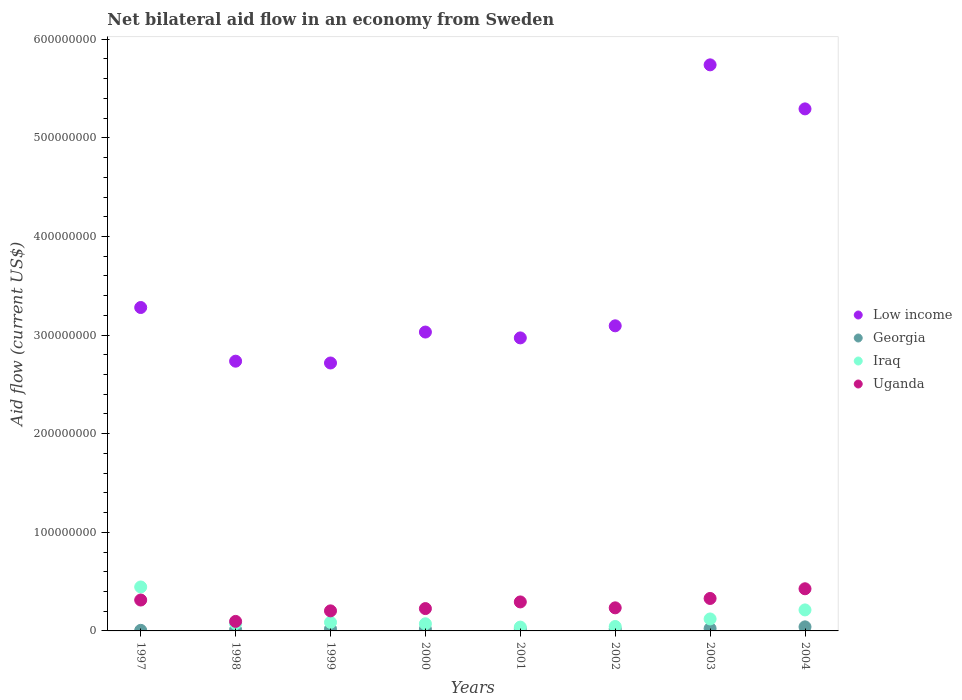How many different coloured dotlines are there?
Provide a short and direct response. 4. What is the net bilateral aid flow in Uganda in 2003?
Offer a terse response. 3.29e+07. Across all years, what is the maximum net bilateral aid flow in Georgia?
Your response must be concise. 4.12e+06. Across all years, what is the minimum net bilateral aid flow in Georgia?
Your answer should be compact. 5.90e+05. In which year was the net bilateral aid flow in Low income minimum?
Ensure brevity in your answer.  1999. What is the total net bilateral aid flow in Uganda in the graph?
Keep it short and to the point. 2.12e+08. What is the difference between the net bilateral aid flow in Low income in 1998 and that in 2001?
Provide a short and direct response. -2.36e+07. What is the difference between the net bilateral aid flow in Georgia in 2001 and the net bilateral aid flow in Uganda in 2000?
Make the answer very short. -2.07e+07. What is the average net bilateral aid flow in Low income per year?
Your answer should be compact. 3.61e+08. In the year 2000, what is the difference between the net bilateral aid flow in Georgia and net bilateral aid flow in Uganda?
Your answer should be very brief. -2.09e+07. What is the ratio of the net bilateral aid flow in Iraq in 1997 to that in 2004?
Ensure brevity in your answer.  2.09. Is the difference between the net bilateral aid flow in Georgia in 1998 and 2004 greater than the difference between the net bilateral aid flow in Uganda in 1998 and 2004?
Offer a very short reply. Yes. What is the difference between the highest and the second highest net bilateral aid flow in Iraq?
Make the answer very short. 2.33e+07. What is the difference between the highest and the lowest net bilateral aid flow in Iraq?
Keep it short and to the point. 4.07e+07. In how many years, is the net bilateral aid flow in Uganda greater than the average net bilateral aid flow in Uganda taken over all years?
Your response must be concise. 4. Is the sum of the net bilateral aid flow in Uganda in 2000 and 2003 greater than the maximum net bilateral aid flow in Iraq across all years?
Your response must be concise. Yes. Does the net bilateral aid flow in Uganda monotonically increase over the years?
Your answer should be very brief. No. Is the net bilateral aid flow in Iraq strictly greater than the net bilateral aid flow in Low income over the years?
Offer a terse response. No. How many years are there in the graph?
Your response must be concise. 8. Does the graph contain grids?
Keep it short and to the point. No. Where does the legend appear in the graph?
Provide a succinct answer. Center right. How many legend labels are there?
Give a very brief answer. 4. What is the title of the graph?
Your answer should be compact. Net bilateral aid flow in an economy from Sweden. Does "Sao Tome and Principe" appear as one of the legend labels in the graph?
Your answer should be very brief. No. What is the label or title of the Y-axis?
Offer a very short reply. Aid flow (current US$). What is the Aid flow (current US$) in Low income in 1997?
Give a very brief answer. 3.28e+08. What is the Aid flow (current US$) in Georgia in 1997?
Keep it short and to the point. 5.90e+05. What is the Aid flow (current US$) of Iraq in 1997?
Provide a short and direct response. 4.46e+07. What is the Aid flow (current US$) in Uganda in 1997?
Ensure brevity in your answer.  3.13e+07. What is the Aid flow (current US$) of Low income in 1998?
Provide a short and direct response. 2.74e+08. What is the Aid flow (current US$) in Georgia in 1998?
Offer a very short reply. 1.27e+06. What is the Aid flow (current US$) in Iraq in 1998?
Your answer should be very brief. 7.46e+06. What is the Aid flow (current US$) of Uganda in 1998?
Offer a terse response. 9.65e+06. What is the Aid flow (current US$) in Low income in 1999?
Provide a short and direct response. 2.72e+08. What is the Aid flow (current US$) of Georgia in 1999?
Your answer should be very brief. 2.03e+06. What is the Aid flow (current US$) in Iraq in 1999?
Provide a succinct answer. 8.66e+06. What is the Aid flow (current US$) in Uganda in 1999?
Ensure brevity in your answer.  2.03e+07. What is the Aid flow (current US$) of Low income in 2000?
Offer a terse response. 3.03e+08. What is the Aid flow (current US$) in Georgia in 2000?
Your response must be concise. 1.77e+06. What is the Aid flow (current US$) of Iraq in 2000?
Provide a succinct answer. 7.23e+06. What is the Aid flow (current US$) of Uganda in 2000?
Provide a succinct answer. 2.26e+07. What is the Aid flow (current US$) of Low income in 2001?
Ensure brevity in your answer.  2.97e+08. What is the Aid flow (current US$) of Georgia in 2001?
Ensure brevity in your answer.  1.99e+06. What is the Aid flow (current US$) of Iraq in 2001?
Provide a short and direct response. 3.87e+06. What is the Aid flow (current US$) in Uganda in 2001?
Give a very brief answer. 2.94e+07. What is the Aid flow (current US$) in Low income in 2002?
Ensure brevity in your answer.  3.09e+08. What is the Aid flow (current US$) of Georgia in 2002?
Your answer should be very brief. 2.02e+06. What is the Aid flow (current US$) of Iraq in 2002?
Give a very brief answer. 4.50e+06. What is the Aid flow (current US$) in Uganda in 2002?
Ensure brevity in your answer.  2.34e+07. What is the Aid flow (current US$) of Low income in 2003?
Your answer should be very brief. 5.74e+08. What is the Aid flow (current US$) of Georgia in 2003?
Give a very brief answer. 2.42e+06. What is the Aid flow (current US$) in Iraq in 2003?
Keep it short and to the point. 1.21e+07. What is the Aid flow (current US$) in Uganda in 2003?
Make the answer very short. 3.29e+07. What is the Aid flow (current US$) in Low income in 2004?
Your answer should be very brief. 5.29e+08. What is the Aid flow (current US$) in Georgia in 2004?
Your answer should be compact. 4.12e+06. What is the Aid flow (current US$) of Iraq in 2004?
Your answer should be very brief. 2.13e+07. What is the Aid flow (current US$) of Uganda in 2004?
Provide a succinct answer. 4.27e+07. Across all years, what is the maximum Aid flow (current US$) of Low income?
Provide a short and direct response. 5.74e+08. Across all years, what is the maximum Aid flow (current US$) of Georgia?
Your response must be concise. 4.12e+06. Across all years, what is the maximum Aid flow (current US$) of Iraq?
Keep it short and to the point. 4.46e+07. Across all years, what is the maximum Aid flow (current US$) of Uganda?
Your response must be concise. 4.27e+07. Across all years, what is the minimum Aid flow (current US$) of Low income?
Your answer should be very brief. 2.72e+08. Across all years, what is the minimum Aid flow (current US$) in Georgia?
Ensure brevity in your answer.  5.90e+05. Across all years, what is the minimum Aid flow (current US$) in Iraq?
Ensure brevity in your answer.  3.87e+06. Across all years, what is the minimum Aid flow (current US$) in Uganda?
Provide a short and direct response. 9.65e+06. What is the total Aid flow (current US$) in Low income in the graph?
Ensure brevity in your answer.  2.89e+09. What is the total Aid flow (current US$) in Georgia in the graph?
Ensure brevity in your answer.  1.62e+07. What is the total Aid flow (current US$) of Iraq in the graph?
Your answer should be very brief. 1.10e+08. What is the total Aid flow (current US$) in Uganda in the graph?
Offer a very short reply. 2.12e+08. What is the difference between the Aid flow (current US$) in Low income in 1997 and that in 1998?
Ensure brevity in your answer.  5.44e+07. What is the difference between the Aid flow (current US$) of Georgia in 1997 and that in 1998?
Provide a succinct answer. -6.80e+05. What is the difference between the Aid flow (current US$) of Iraq in 1997 and that in 1998?
Give a very brief answer. 3.71e+07. What is the difference between the Aid flow (current US$) of Uganda in 1997 and that in 1998?
Give a very brief answer. 2.17e+07. What is the difference between the Aid flow (current US$) of Low income in 1997 and that in 1999?
Provide a short and direct response. 5.63e+07. What is the difference between the Aid flow (current US$) of Georgia in 1997 and that in 1999?
Your answer should be very brief. -1.44e+06. What is the difference between the Aid flow (current US$) in Iraq in 1997 and that in 1999?
Make the answer very short. 3.59e+07. What is the difference between the Aid flow (current US$) in Uganda in 1997 and that in 1999?
Your response must be concise. 1.10e+07. What is the difference between the Aid flow (current US$) of Low income in 1997 and that in 2000?
Give a very brief answer. 2.49e+07. What is the difference between the Aid flow (current US$) of Georgia in 1997 and that in 2000?
Offer a terse response. -1.18e+06. What is the difference between the Aid flow (current US$) in Iraq in 1997 and that in 2000?
Keep it short and to the point. 3.73e+07. What is the difference between the Aid flow (current US$) in Uganda in 1997 and that in 2000?
Provide a short and direct response. 8.68e+06. What is the difference between the Aid flow (current US$) in Low income in 1997 and that in 2001?
Offer a terse response. 3.08e+07. What is the difference between the Aid flow (current US$) in Georgia in 1997 and that in 2001?
Your answer should be very brief. -1.40e+06. What is the difference between the Aid flow (current US$) in Iraq in 1997 and that in 2001?
Provide a short and direct response. 4.07e+07. What is the difference between the Aid flow (current US$) in Uganda in 1997 and that in 2001?
Give a very brief answer. 1.93e+06. What is the difference between the Aid flow (current US$) of Low income in 1997 and that in 2002?
Give a very brief answer. 1.86e+07. What is the difference between the Aid flow (current US$) of Georgia in 1997 and that in 2002?
Give a very brief answer. -1.43e+06. What is the difference between the Aid flow (current US$) in Iraq in 1997 and that in 2002?
Your answer should be compact. 4.01e+07. What is the difference between the Aid flow (current US$) of Uganda in 1997 and that in 2002?
Keep it short and to the point. 7.92e+06. What is the difference between the Aid flow (current US$) of Low income in 1997 and that in 2003?
Your response must be concise. -2.46e+08. What is the difference between the Aid flow (current US$) of Georgia in 1997 and that in 2003?
Your answer should be compact. -1.83e+06. What is the difference between the Aid flow (current US$) of Iraq in 1997 and that in 2003?
Provide a succinct answer. 3.24e+07. What is the difference between the Aid flow (current US$) of Uganda in 1997 and that in 2003?
Keep it short and to the point. -1.59e+06. What is the difference between the Aid flow (current US$) of Low income in 1997 and that in 2004?
Your answer should be very brief. -2.01e+08. What is the difference between the Aid flow (current US$) of Georgia in 1997 and that in 2004?
Your answer should be compact. -3.53e+06. What is the difference between the Aid flow (current US$) of Iraq in 1997 and that in 2004?
Make the answer very short. 2.33e+07. What is the difference between the Aid flow (current US$) of Uganda in 1997 and that in 2004?
Ensure brevity in your answer.  -1.14e+07. What is the difference between the Aid flow (current US$) in Low income in 1998 and that in 1999?
Make the answer very short. 1.84e+06. What is the difference between the Aid flow (current US$) in Georgia in 1998 and that in 1999?
Offer a terse response. -7.60e+05. What is the difference between the Aid flow (current US$) in Iraq in 1998 and that in 1999?
Make the answer very short. -1.20e+06. What is the difference between the Aid flow (current US$) in Uganda in 1998 and that in 1999?
Keep it short and to the point. -1.07e+07. What is the difference between the Aid flow (current US$) in Low income in 1998 and that in 2000?
Your answer should be compact. -2.95e+07. What is the difference between the Aid flow (current US$) of Georgia in 1998 and that in 2000?
Offer a terse response. -5.00e+05. What is the difference between the Aid flow (current US$) in Iraq in 1998 and that in 2000?
Provide a short and direct response. 2.30e+05. What is the difference between the Aid flow (current US$) in Uganda in 1998 and that in 2000?
Your answer should be very brief. -1.30e+07. What is the difference between the Aid flow (current US$) of Low income in 1998 and that in 2001?
Offer a terse response. -2.36e+07. What is the difference between the Aid flow (current US$) of Georgia in 1998 and that in 2001?
Offer a very short reply. -7.20e+05. What is the difference between the Aid flow (current US$) in Iraq in 1998 and that in 2001?
Ensure brevity in your answer.  3.59e+06. What is the difference between the Aid flow (current US$) of Uganda in 1998 and that in 2001?
Offer a very short reply. -1.98e+07. What is the difference between the Aid flow (current US$) in Low income in 1998 and that in 2002?
Your answer should be compact. -3.59e+07. What is the difference between the Aid flow (current US$) of Georgia in 1998 and that in 2002?
Your answer should be compact. -7.50e+05. What is the difference between the Aid flow (current US$) of Iraq in 1998 and that in 2002?
Give a very brief answer. 2.96e+06. What is the difference between the Aid flow (current US$) of Uganda in 1998 and that in 2002?
Your answer should be compact. -1.38e+07. What is the difference between the Aid flow (current US$) in Low income in 1998 and that in 2003?
Ensure brevity in your answer.  -3.00e+08. What is the difference between the Aid flow (current US$) in Georgia in 1998 and that in 2003?
Your response must be concise. -1.15e+06. What is the difference between the Aid flow (current US$) in Iraq in 1998 and that in 2003?
Provide a succinct answer. -4.67e+06. What is the difference between the Aid flow (current US$) of Uganda in 1998 and that in 2003?
Offer a very short reply. -2.33e+07. What is the difference between the Aid flow (current US$) in Low income in 1998 and that in 2004?
Your response must be concise. -2.56e+08. What is the difference between the Aid flow (current US$) of Georgia in 1998 and that in 2004?
Ensure brevity in your answer.  -2.85e+06. What is the difference between the Aid flow (current US$) in Iraq in 1998 and that in 2004?
Provide a short and direct response. -1.38e+07. What is the difference between the Aid flow (current US$) in Uganda in 1998 and that in 2004?
Provide a short and direct response. -3.31e+07. What is the difference between the Aid flow (current US$) in Low income in 1999 and that in 2000?
Ensure brevity in your answer.  -3.14e+07. What is the difference between the Aid flow (current US$) in Georgia in 1999 and that in 2000?
Offer a terse response. 2.60e+05. What is the difference between the Aid flow (current US$) in Iraq in 1999 and that in 2000?
Your answer should be very brief. 1.43e+06. What is the difference between the Aid flow (current US$) in Uganda in 1999 and that in 2000?
Provide a succinct answer. -2.31e+06. What is the difference between the Aid flow (current US$) in Low income in 1999 and that in 2001?
Offer a very short reply. -2.54e+07. What is the difference between the Aid flow (current US$) of Iraq in 1999 and that in 2001?
Your answer should be compact. 4.79e+06. What is the difference between the Aid flow (current US$) in Uganda in 1999 and that in 2001?
Offer a very short reply. -9.06e+06. What is the difference between the Aid flow (current US$) in Low income in 1999 and that in 2002?
Offer a terse response. -3.77e+07. What is the difference between the Aid flow (current US$) in Iraq in 1999 and that in 2002?
Ensure brevity in your answer.  4.16e+06. What is the difference between the Aid flow (current US$) of Uganda in 1999 and that in 2002?
Offer a very short reply. -3.07e+06. What is the difference between the Aid flow (current US$) of Low income in 1999 and that in 2003?
Your response must be concise. -3.02e+08. What is the difference between the Aid flow (current US$) of Georgia in 1999 and that in 2003?
Provide a short and direct response. -3.90e+05. What is the difference between the Aid flow (current US$) of Iraq in 1999 and that in 2003?
Give a very brief answer. -3.47e+06. What is the difference between the Aid flow (current US$) of Uganda in 1999 and that in 2003?
Offer a terse response. -1.26e+07. What is the difference between the Aid flow (current US$) in Low income in 1999 and that in 2004?
Offer a terse response. -2.58e+08. What is the difference between the Aid flow (current US$) of Georgia in 1999 and that in 2004?
Offer a terse response. -2.09e+06. What is the difference between the Aid flow (current US$) of Iraq in 1999 and that in 2004?
Your response must be concise. -1.26e+07. What is the difference between the Aid flow (current US$) in Uganda in 1999 and that in 2004?
Offer a terse response. -2.24e+07. What is the difference between the Aid flow (current US$) of Low income in 2000 and that in 2001?
Keep it short and to the point. 5.94e+06. What is the difference between the Aid flow (current US$) in Georgia in 2000 and that in 2001?
Offer a terse response. -2.20e+05. What is the difference between the Aid flow (current US$) in Iraq in 2000 and that in 2001?
Your answer should be very brief. 3.36e+06. What is the difference between the Aid flow (current US$) of Uganda in 2000 and that in 2001?
Provide a succinct answer. -6.75e+06. What is the difference between the Aid flow (current US$) of Low income in 2000 and that in 2002?
Make the answer very short. -6.32e+06. What is the difference between the Aid flow (current US$) of Georgia in 2000 and that in 2002?
Provide a short and direct response. -2.50e+05. What is the difference between the Aid flow (current US$) of Iraq in 2000 and that in 2002?
Ensure brevity in your answer.  2.73e+06. What is the difference between the Aid flow (current US$) of Uganda in 2000 and that in 2002?
Offer a very short reply. -7.60e+05. What is the difference between the Aid flow (current US$) of Low income in 2000 and that in 2003?
Give a very brief answer. -2.71e+08. What is the difference between the Aid flow (current US$) in Georgia in 2000 and that in 2003?
Offer a very short reply. -6.50e+05. What is the difference between the Aid flow (current US$) in Iraq in 2000 and that in 2003?
Provide a short and direct response. -4.90e+06. What is the difference between the Aid flow (current US$) of Uganda in 2000 and that in 2003?
Offer a very short reply. -1.03e+07. What is the difference between the Aid flow (current US$) in Low income in 2000 and that in 2004?
Provide a short and direct response. -2.26e+08. What is the difference between the Aid flow (current US$) of Georgia in 2000 and that in 2004?
Offer a terse response. -2.35e+06. What is the difference between the Aid flow (current US$) in Iraq in 2000 and that in 2004?
Provide a succinct answer. -1.41e+07. What is the difference between the Aid flow (current US$) of Uganda in 2000 and that in 2004?
Offer a very short reply. -2.01e+07. What is the difference between the Aid flow (current US$) of Low income in 2001 and that in 2002?
Keep it short and to the point. -1.23e+07. What is the difference between the Aid flow (current US$) of Iraq in 2001 and that in 2002?
Offer a very short reply. -6.30e+05. What is the difference between the Aid flow (current US$) of Uganda in 2001 and that in 2002?
Provide a succinct answer. 5.99e+06. What is the difference between the Aid flow (current US$) in Low income in 2001 and that in 2003?
Ensure brevity in your answer.  -2.77e+08. What is the difference between the Aid flow (current US$) in Georgia in 2001 and that in 2003?
Give a very brief answer. -4.30e+05. What is the difference between the Aid flow (current US$) of Iraq in 2001 and that in 2003?
Make the answer very short. -8.26e+06. What is the difference between the Aid flow (current US$) in Uganda in 2001 and that in 2003?
Your answer should be very brief. -3.52e+06. What is the difference between the Aid flow (current US$) in Low income in 2001 and that in 2004?
Ensure brevity in your answer.  -2.32e+08. What is the difference between the Aid flow (current US$) in Georgia in 2001 and that in 2004?
Provide a succinct answer. -2.13e+06. What is the difference between the Aid flow (current US$) of Iraq in 2001 and that in 2004?
Your response must be concise. -1.74e+07. What is the difference between the Aid flow (current US$) in Uganda in 2001 and that in 2004?
Your response must be concise. -1.33e+07. What is the difference between the Aid flow (current US$) of Low income in 2002 and that in 2003?
Provide a short and direct response. -2.65e+08. What is the difference between the Aid flow (current US$) of Georgia in 2002 and that in 2003?
Make the answer very short. -4.00e+05. What is the difference between the Aid flow (current US$) in Iraq in 2002 and that in 2003?
Keep it short and to the point. -7.63e+06. What is the difference between the Aid flow (current US$) of Uganda in 2002 and that in 2003?
Offer a very short reply. -9.51e+06. What is the difference between the Aid flow (current US$) in Low income in 2002 and that in 2004?
Make the answer very short. -2.20e+08. What is the difference between the Aid flow (current US$) in Georgia in 2002 and that in 2004?
Ensure brevity in your answer.  -2.10e+06. What is the difference between the Aid flow (current US$) in Iraq in 2002 and that in 2004?
Give a very brief answer. -1.68e+07. What is the difference between the Aid flow (current US$) of Uganda in 2002 and that in 2004?
Your answer should be very brief. -1.93e+07. What is the difference between the Aid flow (current US$) of Low income in 2003 and that in 2004?
Provide a short and direct response. 4.47e+07. What is the difference between the Aid flow (current US$) of Georgia in 2003 and that in 2004?
Make the answer very short. -1.70e+06. What is the difference between the Aid flow (current US$) of Iraq in 2003 and that in 2004?
Your response must be concise. -9.17e+06. What is the difference between the Aid flow (current US$) of Uganda in 2003 and that in 2004?
Keep it short and to the point. -9.82e+06. What is the difference between the Aid flow (current US$) in Low income in 1997 and the Aid flow (current US$) in Georgia in 1998?
Provide a short and direct response. 3.27e+08. What is the difference between the Aid flow (current US$) of Low income in 1997 and the Aid flow (current US$) of Iraq in 1998?
Ensure brevity in your answer.  3.21e+08. What is the difference between the Aid flow (current US$) of Low income in 1997 and the Aid flow (current US$) of Uganda in 1998?
Your answer should be compact. 3.18e+08. What is the difference between the Aid flow (current US$) of Georgia in 1997 and the Aid flow (current US$) of Iraq in 1998?
Your answer should be compact. -6.87e+06. What is the difference between the Aid flow (current US$) of Georgia in 1997 and the Aid flow (current US$) of Uganda in 1998?
Ensure brevity in your answer.  -9.06e+06. What is the difference between the Aid flow (current US$) in Iraq in 1997 and the Aid flow (current US$) in Uganda in 1998?
Your response must be concise. 3.49e+07. What is the difference between the Aid flow (current US$) in Low income in 1997 and the Aid flow (current US$) in Georgia in 1999?
Make the answer very short. 3.26e+08. What is the difference between the Aid flow (current US$) in Low income in 1997 and the Aid flow (current US$) in Iraq in 1999?
Offer a very short reply. 3.19e+08. What is the difference between the Aid flow (current US$) in Low income in 1997 and the Aid flow (current US$) in Uganda in 1999?
Give a very brief answer. 3.08e+08. What is the difference between the Aid flow (current US$) in Georgia in 1997 and the Aid flow (current US$) in Iraq in 1999?
Your answer should be very brief. -8.07e+06. What is the difference between the Aid flow (current US$) of Georgia in 1997 and the Aid flow (current US$) of Uganda in 1999?
Ensure brevity in your answer.  -1.98e+07. What is the difference between the Aid flow (current US$) of Iraq in 1997 and the Aid flow (current US$) of Uganda in 1999?
Your response must be concise. 2.42e+07. What is the difference between the Aid flow (current US$) in Low income in 1997 and the Aid flow (current US$) in Georgia in 2000?
Your answer should be very brief. 3.26e+08. What is the difference between the Aid flow (current US$) of Low income in 1997 and the Aid flow (current US$) of Iraq in 2000?
Make the answer very short. 3.21e+08. What is the difference between the Aid flow (current US$) of Low income in 1997 and the Aid flow (current US$) of Uganda in 2000?
Give a very brief answer. 3.05e+08. What is the difference between the Aid flow (current US$) of Georgia in 1997 and the Aid flow (current US$) of Iraq in 2000?
Provide a succinct answer. -6.64e+06. What is the difference between the Aid flow (current US$) in Georgia in 1997 and the Aid flow (current US$) in Uganda in 2000?
Provide a short and direct response. -2.21e+07. What is the difference between the Aid flow (current US$) in Iraq in 1997 and the Aid flow (current US$) in Uganda in 2000?
Your answer should be very brief. 2.19e+07. What is the difference between the Aid flow (current US$) in Low income in 1997 and the Aid flow (current US$) in Georgia in 2001?
Provide a short and direct response. 3.26e+08. What is the difference between the Aid flow (current US$) in Low income in 1997 and the Aid flow (current US$) in Iraq in 2001?
Offer a very short reply. 3.24e+08. What is the difference between the Aid flow (current US$) of Low income in 1997 and the Aid flow (current US$) of Uganda in 2001?
Provide a short and direct response. 2.99e+08. What is the difference between the Aid flow (current US$) in Georgia in 1997 and the Aid flow (current US$) in Iraq in 2001?
Your answer should be very brief. -3.28e+06. What is the difference between the Aid flow (current US$) of Georgia in 1997 and the Aid flow (current US$) of Uganda in 2001?
Ensure brevity in your answer.  -2.88e+07. What is the difference between the Aid flow (current US$) in Iraq in 1997 and the Aid flow (current US$) in Uganda in 2001?
Your answer should be very brief. 1.52e+07. What is the difference between the Aid flow (current US$) in Low income in 1997 and the Aid flow (current US$) in Georgia in 2002?
Give a very brief answer. 3.26e+08. What is the difference between the Aid flow (current US$) in Low income in 1997 and the Aid flow (current US$) in Iraq in 2002?
Ensure brevity in your answer.  3.23e+08. What is the difference between the Aid flow (current US$) of Low income in 1997 and the Aid flow (current US$) of Uganda in 2002?
Keep it short and to the point. 3.05e+08. What is the difference between the Aid flow (current US$) of Georgia in 1997 and the Aid flow (current US$) of Iraq in 2002?
Provide a succinct answer. -3.91e+06. What is the difference between the Aid flow (current US$) of Georgia in 1997 and the Aid flow (current US$) of Uganda in 2002?
Your response must be concise. -2.28e+07. What is the difference between the Aid flow (current US$) in Iraq in 1997 and the Aid flow (current US$) in Uganda in 2002?
Your answer should be compact. 2.12e+07. What is the difference between the Aid flow (current US$) in Low income in 1997 and the Aid flow (current US$) in Georgia in 2003?
Your answer should be compact. 3.26e+08. What is the difference between the Aid flow (current US$) in Low income in 1997 and the Aid flow (current US$) in Iraq in 2003?
Make the answer very short. 3.16e+08. What is the difference between the Aid flow (current US$) of Low income in 1997 and the Aid flow (current US$) of Uganda in 2003?
Your answer should be very brief. 2.95e+08. What is the difference between the Aid flow (current US$) of Georgia in 1997 and the Aid flow (current US$) of Iraq in 2003?
Your response must be concise. -1.15e+07. What is the difference between the Aid flow (current US$) of Georgia in 1997 and the Aid flow (current US$) of Uganda in 2003?
Ensure brevity in your answer.  -3.23e+07. What is the difference between the Aid flow (current US$) of Iraq in 1997 and the Aid flow (current US$) of Uganda in 2003?
Keep it short and to the point. 1.16e+07. What is the difference between the Aid flow (current US$) in Low income in 1997 and the Aid flow (current US$) in Georgia in 2004?
Make the answer very short. 3.24e+08. What is the difference between the Aid flow (current US$) in Low income in 1997 and the Aid flow (current US$) in Iraq in 2004?
Provide a succinct answer. 3.07e+08. What is the difference between the Aid flow (current US$) in Low income in 1997 and the Aid flow (current US$) in Uganda in 2004?
Provide a short and direct response. 2.85e+08. What is the difference between the Aid flow (current US$) in Georgia in 1997 and the Aid flow (current US$) in Iraq in 2004?
Keep it short and to the point. -2.07e+07. What is the difference between the Aid flow (current US$) in Georgia in 1997 and the Aid flow (current US$) in Uganda in 2004?
Provide a succinct answer. -4.22e+07. What is the difference between the Aid flow (current US$) of Iraq in 1997 and the Aid flow (current US$) of Uganda in 2004?
Offer a very short reply. 1.83e+06. What is the difference between the Aid flow (current US$) of Low income in 1998 and the Aid flow (current US$) of Georgia in 1999?
Your answer should be compact. 2.72e+08. What is the difference between the Aid flow (current US$) in Low income in 1998 and the Aid flow (current US$) in Iraq in 1999?
Offer a very short reply. 2.65e+08. What is the difference between the Aid flow (current US$) of Low income in 1998 and the Aid flow (current US$) of Uganda in 1999?
Provide a short and direct response. 2.53e+08. What is the difference between the Aid flow (current US$) in Georgia in 1998 and the Aid flow (current US$) in Iraq in 1999?
Your response must be concise. -7.39e+06. What is the difference between the Aid flow (current US$) in Georgia in 1998 and the Aid flow (current US$) in Uganda in 1999?
Your response must be concise. -1.91e+07. What is the difference between the Aid flow (current US$) in Iraq in 1998 and the Aid flow (current US$) in Uganda in 1999?
Make the answer very short. -1.29e+07. What is the difference between the Aid flow (current US$) in Low income in 1998 and the Aid flow (current US$) in Georgia in 2000?
Offer a terse response. 2.72e+08. What is the difference between the Aid flow (current US$) of Low income in 1998 and the Aid flow (current US$) of Iraq in 2000?
Make the answer very short. 2.66e+08. What is the difference between the Aid flow (current US$) of Low income in 1998 and the Aid flow (current US$) of Uganda in 2000?
Provide a succinct answer. 2.51e+08. What is the difference between the Aid flow (current US$) in Georgia in 1998 and the Aid flow (current US$) in Iraq in 2000?
Provide a short and direct response. -5.96e+06. What is the difference between the Aid flow (current US$) of Georgia in 1998 and the Aid flow (current US$) of Uganda in 2000?
Your answer should be very brief. -2.14e+07. What is the difference between the Aid flow (current US$) in Iraq in 1998 and the Aid flow (current US$) in Uganda in 2000?
Provide a short and direct response. -1.52e+07. What is the difference between the Aid flow (current US$) in Low income in 1998 and the Aid flow (current US$) in Georgia in 2001?
Your response must be concise. 2.72e+08. What is the difference between the Aid flow (current US$) in Low income in 1998 and the Aid flow (current US$) in Iraq in 2001?
Offer a terse response. 2.70e+08. What is the difference between the Aid flow (current US$) in Low income in 1998 and the Aid flow (current US$) in Uganda in 2001?
Keep it short and to the point. 2.44e+08. What is the difference between the Aid flow (current US$) of Georgia in 1998 and the Aid flow (current US$) of Iraq in 2001?
Your response must be concise. -2.60e+06. What is the difference between the Aid flow (current US$) in Georgia in 1998 and the Aid flow (current US$) in Uganda in 2001?
Provide a short and direct response. -2.81e+07. What is the difference between the Aid flow (current US$) in Iraq in 1998 and the Aid flow (current US$) in Uganda in 2001?
Offer a very short reply. -2.19e+07. What is the difference between the Aid flow (current US$) of Low income in 1998 and the Aid flow (current US$) of Georgia in 2002?
Provide a succinct answer. 2.72e+08. What is the difference between the Aid flow (current US$) of Low income in 1998 and the Aid flow (current US$) of Iraq in 2002?
Your response must be concise. 2.69e+08. What is the difference between the Aid flow (current US$) of Low income in 1998 and the Aid flow (current US$) of Uganda in 2002?
Your response must be concise. 2.50e+08. What is the difference between the Aid flow (current US$) of Georgia in 1998 and the Aid flow (current US$) of Iraq in 2002?
Provide a succinct answer. -3.23e+06. What is the difference between the Aid flow (current US$) of Georgia in 1998 and the Aid flow (current US$) of Uganda in 2002?
Your response must be concise. -2.21e+07. What is the difference between the Aid flow (current US$) of Iraq in 1998 and the Aid flow (current US$) of Uganda in 2002?
Make the answer very short. -1.60e+07. What is the difference between the Aid flow (current US$) of Low income in 1998 and the Aid flow (current US$) of Georgia in 2003?
Provide a succinct answer. 2.71e+08. What is the difference between the Aid flow (current US$) in Low income in 1998 and the Aid flow (current US$) in Iraq in 2003?
Your answer should be very brief. 2.61e+08. What is the difference between the Aid flow (current US$) in Low income in 1998 and the Aid flow (current US$) in Uganda in 2003?
Provide a short and direct response. 2.41e+08. What is the difference between the Aid flow (current US$) of Georgia in 1998 and the Aid flow (current US$) of Iraq in 2003?
Make the answer very short. -1.09e+07. What is the difference between the Aid flow (current US$) in Georgia in 1998 and the Aid flow (current US$) in Uganda in 2003?
Your answer should be compact. -3.16e+07. What is the difference between the Aid flow (current US$) in Iraq in 1998 and the Aid flow (current US$) in Uganda in 2003?
Your response must be concise. -2.55e+07. What is the difference between the Aid flow (current US$) in Low income in 1998 and the Aid flow (current US$) in Georgia in 2004?
Your answer should be very brief. 2.69e+08. What is the difference between the Aid flow (current US$) of Low income in 1998 and the Aid flow (current US$) of Iraq in 2004?
Provide a short and direct response. 2.52e+08. What is the difference between the Aid flow (current US$) in Low income in 1998 and the Aid flow (current US$) in Uganda in 2004?
Your response must be concise. 2.31e+08. What is the difference between the Aid flow (current US$) of Georgia in 1998 and the Aid flow (current US$) of Iraq in 2004?
Ensure brevity in your answer.  -2.00e+07. What is the difference between the Aid flow (current US$) of Georgia in 1998 and the Aid flow (current US$) of Uganda in 2004?
Ensure brevity in your answer.  -4.15e+07. What is the difference between the Aid flow (current US$) of Iraq in 1998 and the Aid flow (current US$) of Uganda in 2004?
Give a very brief answer. -3.53e+07. What is the difference between the Aid flow (current US$) of Low income in 1999 and the Aid flow (current US$) of Georgia in 2000?
Keep it short and to the point. 2.70e+08. What is the difference between the Aid flow (current US$) of Low income in 1999 and the Aid flow (current US$) of Iraq in 2000?
Keep it short and to the point. 2.64e+08. What is the difference between the Aid flow (current US$) in Low income in 1999 and the Aid flow (current US$) in Uganda in 2000?
Your answer should be very brief. 2.49e+08. What is the difference between the Aid flow (current US$) in Georgia in 1999 and the Aid flow (current US$) in Iraq in 2000?
Provide a succinct answer. -5.20e+06. What is the difference between the Aid flow (current US$) of Georgia in 1999 and the Aid flow (current US$) of Uganda in 2000?
Offer a terse response. -2.06e+07. What is the difference between the Aid flow (current US$) in Iraq in 1999 and the Aid flow (current US$) in Uganda in 2000?
Provide a short and direct response. -1.40e+07. What is the difference between the Aid flow (current US$) in Low income in 1999 and the Aid flow (current US$) in Georgia in 2001?
Your response must be concise. 2.70e+08. What is the difference between the Aid flow (current US$) of Low income in 1999 and the Aid flow (current US$) of Iraq in 2001?
Offer a terse response. 2.68e+08. What is the difference between the Aid flow (current US$) in Low income in 1999 and the Aid flow (current US$) in Uganda in 2001?
Your response must be concise. 2.42e+08. What is the difference between the Aid flow (current US$) in Georgia in 1999 and the Aid flow (current US$) in Iraq in 2001?
Give a very brief answer. -1.84e+06. What is the difference between the Aid flow (current US$) in Georgia in 1999 and the Aid flow (current US$) in Uganda in 2001?
Offer a terse response. -2.74e+07. What is the difference between the Aid flow (current US$) of Iraq in 1999 and the Aid flow (current US$) of Uganda in 2001?
Offer a very short reply. -2.07e+07. What is the difference between the Aid flow (current US$) in Low income in 1999 and the Aid flow (current US$) in Georgia in 2002?
Provide a short and direct response. 2.70e+08. What is the difference between the Aid flow (current US$) of Low income in 1999 and the Aid flow (current US$) of Iraq in 2002?
Your answer should be very brief. 2.67e+08. What is the difference between the Aid flow (current US$) of Low income in 1999 and the Aid flow (current US$) of Uganda in 2002?
Offer a very short reply. 2.48e+08. What is the difference between the Aid flow (current US$) in Georgia in 1999 and the Aid flow (current US$) in Iraq in 2002?
Your response must be concise. -2.47e+06. What is the difference between the Aid flow (current US$) of Georgia in 1999 and the Aid flow (current US$) of Uganda in 2002?
Offer a very short reply. -2.14e+07. What is the difference between the Aid flow (current US$) in Iraq in 1999 and the Aid flow (current US$) in Uganda in 2002?
Your answer should be very brief. -1.48e+07. What is the difference between the Aid flow (current US$) in Low income in 1999 and the Aid flow (current US$) in Georgia in 2003?
Make the answer very short. 2.69e+08. What is the difference between the Aid flow (current US$) of Low income in 1999 and the Aid flow (current US$) of Iraq in 2003?
Keep it short and to the point. 2.60e+08. What is the difference between the Aid flow (current US$) in Low income in 1999 and the Aid flow (current US$) in Uganda in 2003?
Keep it short and to the point. 2.39e+08. What is the difference between the Aid flow (current US$) of Georgia in 1999 and the Aid flow (current US$) of Iraq in 2003?
Keep it short and to the point. -1.01e+07. What is the difference between the Aid flow (current US$) of Georgia in 1999 and the Aid flow (current US$) of Uganda in 2003?
Give a very brief answer. -3.09e+07. What is the difference between the Aid flow (current US$) in Iraq in 1999 and the Aid flow (current US$) in Uganda in 2003?
Ensure brevity in your answer.  -2.43e+07. What is the difference between the Aid flow (current US$) in Low income in 1999 and the Aid flow (current US$) in Georgia in 2004?
Your response must be concise. 2.68e+08. What is the difference between the Aid flow (current US$) of Low income in 1999 and the Aid flow (current US$) of Iraq in 2004?
Your answer should be compact. 2.50e+08. What is the difference between the Aid flow (current US$) of Low income in 1999 and the Aid flow (current US$) of Uganda in 2004?
Make the answer very short. 2.29e+08. What is the difference between the Aid flow (current US$) in Georgia in 1999 and the Aid flow (current US$) in Iraq in 2004?
Provide a short and direct response. -1.93e+07. What is the difference between the Aid flow (current US$) in Georgia in 1999 and the Aid flow (current US$) in Uganda in 2004?
Give a very brief answer. -4.07e+07. What is the difference between the Aid flow (current US$) of Iraq in 1999 and the Aid flow (current US$) of Uganda in 2004?
Your answer should be very brief. -3.41e+07. What is the difference between the Aid flow (current US$) of Low income in 2000 and the Aid flow (current US$) of Georgia in 2001?
Offer a terse response. 3.01e+08. What is the difference between the Aid flow (current US$) in Low income in 2000 and the Aid flow (current US$) in Iraq in 2001?
Give a very brief answer. 2.99e+08. What is the difference between the Aid flow (current US$) in Low income in 2000 and the Aid flow (current US$) in Uganda in 2001?
Your answer should be compact. 2.74e+08. What is the difference between the Aid flow (current US$) in Georgia in 2000 and the Aid flow (current US$) in Iraq in 2001?
Ensure brevity in your answer.  -2.10e+06. What is the difference between the Aid flow (current US$) in Georgia in 2000 and the Aid flow (current US$) in Uganda in 2001?
Provide a succinct answer. -2.76e+07. What is the difference between the Aid flow (current US$) of Iraq in 2000 and the Aid flow (current US$) of Uganda in 2001?
Offer a terse response. -2.22e+07. What is the difference between the Aid flow (current US$) in Low income in 2000 and the Aid flow (current US$) in Georgia in 2002?
Ensure brevity in your answer.  3.01e+08. What is the difference between the Aid flow (current US$) of Low income in 2000 and the Aid flow (current US$) of Iraq in 2002?
Your answer should be very brief. 2.99e+08. What is the difference between the Aid flow (current US$) in Low income in 2000 and the Aid flow (current US$) in Uganda in 2002?
Your answer should be very brief. 2.80e+08. What is the difference between the Aid flow (current US$) of Georgia in 2000 and the Aid flow (current US$) of Iraq in 2002?
Offer a very short reply. -2.73e+06. What is the difference between the Aid flow (current US$) in Georgia in 2000 and the Aid flow (current US$) in Uganda in 2002?
Keep it short and to the point. -2.16e+07. What is the difference between the Aid flow (current US$) in Iraq in 2000 and the Aid flow (current US$) in Uganda in 2002?
Offer a very short reply. -1.62e+07. What is the difference between the Aid flow (current US$) of Low income in 2000 and the Aid flow (current US$) of Georgia in 2003?
Offer a very short reply. 3.01e+08. What is the difference between the Aid flow (current US$) in Low income in 2000 and the Aid flow (current US$) in Iraq in 2003?
Your answer should be compact. 2.91e+08. What is the difference between the Aid flow (current US$) of Low income in 2000 and the Aid flow (current US$) of Uganda in 2003?
Make the answer very short. 2.70e+08. What is the difference between the Aid flow (current US$) of Georgia in 2000 and the Aid flow (current US$) of Iraq in 2003?
Your answer should be compact. -1.04e+07. What is the difference between the Aid flow (current US$) of Georgia in 2000 and the Aid flow (current US$) of Uganda in 2003?
Offer a very short reply. -3.12e+07. What is the difference between the Aid flow (current US$) of Iraq in 2000 and the Aid flow (current US$) of Uganda in 2003?
Your answer should be compact. -2.57e+07. What is the difference between the Aid flow (current US$) in Low income in 2000 and the Aid flow (current US$) in Georgia in 2004?
Provide a succinct answer. 2.99e+08. What is the difference between the Aid flow (current US$) in Low income in 2000 and the Aid flow (current US$) in Iraq in 2004?
Make the answer very short. 2.82e+08. What is the difference between the Aid flow (current US$) in Low income in 2000 and the Aid flow (current US$) in Uganda in 2004?
Provide a succinct answer. 2.60e+08. What is the difference between the Aid flow (current US$) in Georgia in 2000 and the Aid flow (current US$) in Iraq in 2004?
Ensure brevity in your answer.  -1.95e+07. What is the difference between the Aid flow (current US$) in Georgia in 2000 and the Aid flow (current US$) in Uganda in 2004?
Keep it short and to the point. -4.10e+07. What is the difference between the Aid flow (current US$) of Iraq in 2000 and the Aid flow (current US$) of Uganda in 2004?
Provide a short and direct response. -3.55e+07. What is the difference between the Aid flow (current US$) in Low income in 2001 and the Aid flow (current US$) in Georgia in 2002?
Your answer should be compact. 2.95e+08. What is the difference between the Aid flow (current US$) of Low income in 2001 and the Aid flow (current US$) of Iraq in 2002?
Provide a short and direct response. 2.93e+08. What is the difference between the Aid flow (current US$) of Low income in 2001 and the Aid flow (current US$) of Uganda in 2002?
Offer a terse response. 2.74e+08. What is the difference between the Aid flow (current US$) of Georgia in 2001 and the Aid flow (current US$) of Iraq in 2002?
Keep it short and to the point. -2.51e+06. What is the difference between the Aid flow (current US$) in Georgia in 2001 and the Aid flow (current US$) in Uganda in 2002?
Keep it short and to the point. -2.14e+07. What is the difference between the Aid flow (current US$) in Iraq in 2001 and the Aid flow (current US$) in Uganda in 2002?
Give a very brief answer. -1.95e+07. What is the difference between the Aid flow (current US$) in Low income in 2001 and the Aid flow (current US$) in Georgia in 2003?
Your answer should be very brief. 2.95e+08. What is the difference between the Aid flow (current US$) of Low income in 2001 and the Aid flow (current US$) of Iraq in 2003?
Your answer should be very brief. 2.85e+08. What is the difference between the Aid flow (current US$) of Low income in 2001 and the Aid flow (current US$) of Uganda in 2003?
Provide a succinct answer. 2.64e+08. What is the difference between the Aid flow (current US$) of Georgia in 2001 and the Aid flow (current US$) of Iraq in 2003?
Your answer should be very brief. -1.01e+07. What is the difference between the Aid flow (current US$) in Georgia in 2001 and the Aid flow (current US$) in Uganda in 2003?
Keep it short and to the point. -3.09e+07. What is the difference between the Aid flow (current US$) of Iraq in 2001 and the Aid flow (current US$) of Uganda in 2003?
Provide a succinct answer. -2.90e+07. What is the difference between the Aid flow (current US$) in Low income in 2001 and the Aid flow (current US$) in Georgia in 2004?
Ensure brevity in your answer.  2.93e+08. What is the difference between the Aid flow (current US$) of Low income in 2001 and the Aid flow (current US$) of Iraq in 2004?
Offer a terse response. 2.76e+08. What is the difference between the Aid flow (current US$) in Low income in 2001 and the Aid flow (current US$) in Uganda in 2004?
Offer a terse response. 2.54e+08. What is the difference between the Aid flow (current US$) of Georgia in 2001 and the Aid flow (current US$) of Iraq in 2004?
Ensure brevity in your answer.  -1.93e+07. What is the difference between the Aid flow (current US$) of Georgia in 2001 and the Aid flow (current US$) of Uganda in 2004?
Provide a short and direct response. -4.08e+07. What is the difference between the Aid flow (current US$) in Iraq in 2001 and the Aid flow (current US$) in Uganda in 2004?
Give a very brief answer. -3.89e+07. What is the difference between the Aid flow (current US$) in Low income in 2002 and the Aid flow (current US$) in Georgia in 2003?
Give a very brief answer. 3.07e+08. What is the difference between the Aid flow (current US$) of Low income in 2002 and the Aid flow (current US$) of Iraq in 2003?
Make the answer very short. 2.97e+08. What is the difference between the Aid flow (current US$) in Low income in 2002 and the Aid flow (current US$) in Uganda in 2003?
Offer a terse response. 2.76e+08. What is the difference between the Aid flow (current US$) in Georgia in 2002 and the Aid flow (current US$) in Iraq in 2003?
Give a very brief answer. -1.01e+07. What is the difference between the Aid flow (current US$) in Georgia in 2002 and the Aid flow (current US$) in Uganda in 2003?
Keep it short and to the point. -3.09e+07. What is the difference between the Aid flow (current US$) in Iraq in 2002 and the Aid flow (current US$) in Uganda in 2003?
Provide a succinct answer. -2.84e+07. What is the difference between the Aid flow (current US$) of Low income in 2002 and the Aid flow (current US$) of Georgia in 2004?
Provide a succinct answer. 3.05e+08. What is the difference between the Aid flow (current US$) in Low income in 2002 and the Aid flow (current US$) in Iraq in 2004?
Offer a very short reply. 2.88e+08. What is the difference between the Aid flow (current US$) in Low income in 2002 and the Aid flow (current US$) in Uganda in 2004?
Your response must be concise. 2.67e+08. What is the difference between the Aid flow (current US$) of Georgia in 2002 and the Aid flow (current US$) of Iraq in 2004?
Offer a terse response. -1.93e+07. What is the difference between the Aid flow (current US$) of Georgia in 2002 and the Aid flow (current US$) of Uganda in 2004?
Your answer should be compact. -4.07e+07. What is the difference between the Aid flow (current US$) of Iraq in 2002 and the Aid flow (current US$) of Uganda in 2004?
Give a very brief answer. -3.82e+07. What is the difference between the Aid flow (current US$) in Low income in 2003 and the Aid flow (current US$) in Georgia in 2004?
Offer a terse response. 5.70e+08. What is the difference between the Aid flow (current US$) in Low income in 2003 and the Aid flow (current US$) in Iraq in 2004?
Give a very brief answer. 5.53e+08. What is the difference between the Aid flow (current US$) in Low income in 2003 and the Aid flow (current US$) in Uganda in 2004?
Provide a succinct answer. 5.31e+08. What is the difference between the Aid flow (current US$) in Georgia in 2003 and the Aid flow (current US$) in Iraq in 2004?
Ensure brevity in your answer.  -1.89e+07. What is the difference between the Aid flow (current US$) of Georgia in 2003 and the Aid flow (current US$) of Uganda in 2004?
Give a very brief answer. -4.03e+07. What is the difference between the Aid flow (current US$) in Iraq in 2003 and the Aid flow (current US$) in Uganda in 2004?
Keep it short and to the point. -3.06e+07. What is the average Aid flow (current US$) of Low income per year?
Provide a succinct answer. 3.61e+08. What is the average Aid flow (current US$) in Georgia per year?
Your answer should be compact. 2.03e+06. What is the average Aid flow (current US$) of Iraq per year?
Offer a terse response. 1.37e+07. What is the average Aid flow (current US$) of Uganda per year?
Give a very brief answer. 2.66e+07. In the year 1997, what is the difference between the Aid flow (current US$) of Low income and Aid flow (current US$) of Georgia?
Your answer should be very brief. 3.27e+08. In the year 1997, what is the difference between the Aid flow (current US$) of Low income and Aid flow (current US$) of Iraq?
Ensure brevity in your answer.  2.83e+08. In the year 1997, what is the difference between the Aid flow (current US$) of Low income and Aid flow (current US$) of Uganda?
Make the answer very short. 2.97e+08. In the year 1997, what is the difference between the Aid flow (current US$) in Georgia and Aid flow (current US$) in Iraq?
Keep it short and to the point. -4.40e+07. In the year 1997, what is the difference between the Aid flow (current US$) of Georgia and Aid flow (current US$) of Uganda?
Make the answer very short. -3.07e+07. In the year 1997, what is the difference between the Aid flow (current US$) of Iraq and Aid flow (current US$) of Uganda?
Make the answer very short. 1.32e+07. In the year 1998, what is the difference between the Aid flow (current US$) in Low income and Aid flow (current US$) in Georgia?
Provide a succinct answer. 2.72e+08. In the year 1998, what is the difference between the Aid flow (current US$) of Low income and Aid flow (current US$) of Iraq?
Your response must be concise. 2.66e+08. In the year 1998, what is the difference between the Aid flow (current US$) of Low income and Aid flow (current US$) of Uganda?
Provide a short and direct response. 2.64e+08. In the year 1998, what is the difference between the Aid flow (current US$) in Georgia and Aid flow (current US$) in Iraq?
Your response must be concise. -6.19e+06. In the year 1998, what is the difference between the Aid flow (current US$) in Georgia and Aid flow (current US$) in Uganda?
Provide a succinct answer. -8.38e+06. In the year 1998, what is the difference between the Aid flow (current US$) in Iraq and Aid flow (current US$) in Uganda?
Your response must be concise. -2.19e+06. In the year 1999, what is the difference between the Aid flow (current US$) in Low income and Aid flow (current US$) in Georgia?
Offer a very short reply. 2.70e+08. In the year 1999, what is the difference between the Aid flow (current US$) in Low income and Aid flow (current US$) in Iraq?
Your answer should be very brief. 2.63e+08. In the year 1999, what is the difference between the Aid flow (current US$) in Low income and Aid flow (current US$) in Uganda?
Offer a terse response. 2.51e+08. In the year 1999, what is the difference between the Aid flow (current US$) in Georgia and Aid flow (current US$) in Iraq?
Your answer should be compact. -6.63e+06. In the year 1999, what is the difference between the Aid flow (current US$) in Georgia and Aid flow (current US$) in Uganda?
Provide a succinct answer. -1.83e+07. In the year 1999, what is the difference between the Aid flow (current US$) in Iraq and Aid flow (current US$) in Uganda?
Make the answer very short. -1.17e+07. In the year 2000, what is the difference between the Aid flow (current US$) of Low income and Aid flow (current US$) of Georgia?
Make the answer very short. 3.01e+08. In the year 2000, what is the difference between the Aid flow (current US$) of Low income and Aid flow (current US$) of Iraq?
Ensure brevity in your answer.  2.96e+08. In the year 2000, what is the difference between the Aid flow (current US$) in Low income and Aid flow (current US$) in Uganda?
Give a very brief answer. 2.80e+08. In the year 2000, what is the difference between the Aid flow (current US$) in Georgia and Aid flow (current US$) in Iraq?
Your answer should be very brief. -5.46e+06. In the year 2000, what is the difference between the Aid flow (current US$) in Georgia and Aid flow (current US$) in Uganda?
Give a very brief answer. -2.09e+07. In the year 2000, what is the difference between the Aid flow (current US$) of Iraq and Aid flow (current US$) of Uganda?
Offer a terse response. -1.54e+07. In the year 2001, what is the difference between the Aid flow (current US$) of Low income and Aid flow (current US$) of Georgia?
Provide a succinct answer. 2.95e+08. In the year 2001, what is the difference between the Aid flow (current US$) of Low income and Aid flow (current US$) of Iraq?
Provide a short and direct response. 2.93e+08. In the year 2001, what is the difference between the Aid flow (current US$) in Low income and Aid flow (current US$) in Uganda?
Provide a succinct answer. 2.68e+08. In the year 2001, what is the difference between the Aid flow (current US$) in Georgia and Aid flow (current US$) in Iraq?
Keep it short and to the point. -1.88e+06. In the year 2001, what is the difference between the Aid flow (current US$) in Georgia and Aid flow (current US$) in Uganda?
Your answer should be compact. -2.74e+07. In the year 2001, what is the difference between the Aid flow (current US$) of Iraq and Aid flow (current US$) of Uganda?
Keep it short and to the point. -2.55e+07. In the year 2002, what is the difference between the Aid flow (current US$) in Low income and Aid flow (current US$) in Georgia?
Provide a succinct answer. 3.07e+08. In the year 2002, what is the difference between the Aid flow (current US$) of Low income and Aid flow (current US$) of Iraq?
Your answer should be very brief. 3.05e+08. In the year 2002, what is the difference between the Aid flow (current US$) of Low income and Aid flow (current US$) of Uganda?
Make the answer very short. 2.86e+08. In the year 2002, what is the difference between the Aid flow (current US$) of Georgia and Aid flow (current US$) of Iraq?
Offer a very short reply. -2.48e+06. In the year 2002, what is the difference between the Aid flow (current US$) of Georgia and Aid flow (current US$) of Uganda?
Keep it short and to the point. -2.14e+07. In the year 2002, what is the difference between the Aid flow (current US$) of Iraq and Aid flow (current US$) of Uganda?
Offer a very short reply. -1.89e+07. In the year 2003, what is the difference between the Aid flow (current US$) in Low income and Aid flow (current US$) in Georgia?
Offer a terse response. 5.72e+08. In the year 2003, what is the difference between the Aid flow (current US$) in Low income and Aid flow (current US$) in Iraq?
Offer a terse response. 5.62e+08. In the year 2003, what is the difference between the Aid flow (current US$) in Low income and Aid flow (current US$) in Uganda?
Ensure brevity in your answer.  5.41e+08. In the year 2003, what is the difference between the Aid flow (current US$) of Georgia and Aid flow (current US$) of Iraq?
Keep it short and to the point. -9.71e+06. In the year 2003, what is the difference between the Aid flow (current US$) of Georgia and Aid flow (current US$) of Uganda?
Make the answer very short. -3.05e+07. In the year 2003, what is the difference between the Aid flow (current US$) in Iraq and Aid flow (current US$) in Uganda?
Offer a very short reply. -2.08e+07. In the year 2004, what is the difference between the Aid flow (current US$) in Low income and Aid flow (current US$) in Georgia?
Make the answer very short. 5.25e+08. In the year 2004, what is the difference between the Aid flow (current US$) in Low income and Aid flow (current US$) in Iraq?
Make the answer very short. 5.08e+08. In the year 2004, what is the difference between the Aid flow (current US$) in Low income and Aid flow (current US$) in Uganda?
Ensure brevity in your answer.  4.87e+08. In the year 2004, what is the difference between the Aid flow (current US$) in Georgia and Aid flow (current US$) in Iraq?
Give a very brief answer. -1.72e+07. In the year 2004, what is the difference between the Aid flow (current US$) in Georgia and Aid flow (current US$) in Uganda?
Provide a short and direct response. -3.86e+07. In the year 2004, what is the difference between the Aid flow (current US$) in Iraq and Aid flow (current US$) in Uganda?
Offer a very short reply. -2.14e+07. What is the ratio of the Aid flow (current US$) of Low income in 1997 to that in 1998?
Your answer should be very brief. 1.2. What is the ratio of the Aid flow (current US$) of Georgia in 1997 to that in 1998?
Keep it short and to the point. 0.46. What is the ratio of the Aid flow (current US$) in Iraq in 1997 to that in 1998?
Give a very brief answer. 5.97. What is the ratio of the Aid flow (current US$) in Uganda in 1997 to that in 1998?
Give a very brief answer. 3.25. What is the ratio of the Aid flow (current US$) in Low income in 1997 to that in 1999?
Your response must be concise. 1.21. What is the ratio of the Aid flow (current US$) in Georgia in 1997 to that in 1999?
Your response must be concise. 0.29. What is the ratio of the Aid flow (current US$) in Iraq in 1997 to that in 1999?
Offer a very short reply. 5.15. What is the ratio of the Aid flow (current US$) of Uganda in 1997 to that in 1999?
Ensure brevity in your answer.  1.54. What is the ratio of the Aid flow (current US$) in Low income in 1997 to that in 2000?
Offer a very short reply. 1.08. What is the ratio of the Aid flow (current US$) of Georgia in 1997 to that in 2000?
Offer a very short reply. 0.33. What is the ratio of the Aid flow (current US$) in Iraq in 1997 to that in 2000?
Provide a short and direct response. 6.16. What is the ratio of the Aid flow (current US$) of Uganda in 1997 to that in 2000?
Keep it short and to the point. 1.38. What is the ratio of the Aid flow (current US$) of Low income in 1997 to that in 2001?
Your response must be concise. 1.1. What is the ratio of the Aid flow (current US$) in Georgia in 1997 to that in 2001?
Give a very brief answer. 0.3. What is the ratio of the Aid flow (current US$) in Iraq in 1997 to that in 2001?
Your answer should be compact. 11.52. What is the ratio of the Aid flow (current US$) in Uganda in 1997 to that in 2001?
Provide a succinct answer. 1.07. What is the ratio of the Aid flow (current US$) of Low income in 1997 to that in 2002?
Offer a very short reply. 1.06. What is the ratio of the Aid flow (current US$) of Georgia in 1997 to that in 2002?
Give a very brief answer. 0.29. What is the ratio of the Aid flow (current US$) in Iraq in 1997 to that in 2002?
Your answer should be compact. 9.9. What is the ratio of the Aid flow (current US$) in Uganda in 1997 to that in 2002?
Ensure brevity in your answer.  1.34. What is the ratio of the Aid flow (current US$) of Low income in 1997 to that in 2003?
Offer a terse response. 0.57. What is the ratio of the Aid flow (current US$) of Georgia in 1997 to that in 2003?
Your answer should be compact. 0.24. What is the ratio of the Aid flow (current US$) in Iraq in 1997 to that in 2003?
Keep it short and to the point. 3.67. What is the ratio of the Aid flow (current US$) of Uganda in 1997 to that in 2003?
Provide a succinct answer. 0.95. What is the ratio of the Aid flow (current US$) of Low income in 1997 to that in 2004?
Make the answer very short. 0.62. What is the ratio of the Aid flow (current US$) in Georgia in 1997 to that in 2004?
Make the answer very short. 0.14. What is the ratio of the Aid flow (current US$) in Iraq in 1997 to that in 2004?
Offer a terse response. 2.09. What is the ratio of the Aid flow (current US$) in Uganda in 1997 to that in 2004?
Provide a short and direct response. 0.73. What is the ratio of the Aid flow (current US$) of Low income in 1998 to that in 1999?
Your answer should be compact. 1.01. What is the ratio of the Aid flow (current US$) in Georgia in 1998 to that in 1999?
Keep it short and to the point. 0.63. What is the ratio of the Aid flow (current US$) in Iraq in 1998 to that in 1999?
Keep it short and to the point. 0.86. What is the ratio of the Aid flow (current US$) in Uganda in 1998 to that in 1999?
Offer a very short reply. 0.47. What is the ratio of the Aid flow (current US$) of Low income in 1998 to that in 2000?
Offer a terse response. 0.9. What is the ratio of the Aid flow (current US$) in Georgia in 1998 to that in 2000?
Your answer should be very brief. 0.72. What is the ratio of the Aid flow (current US$) of Iraq in 1998 to that in 2000?
Give a very brief answer. 1.03. What is the ratio of the Aid flow (current US$) of Uganda in 1998 to that in 2000?
Make the answer very short. 0.43. What is the ratio of the Aid flow (current US$) in Low income in 1998 to that in 2001?
Provide a short and direct response. 0.92. What is the ratio of the Aid flow (current US$) in Georgia in 1998 to that in 2001?
Ensure brevity in your answer.  0.64. What is the ratio of the Aid flow (current US$) of Iraq in 1998 to that in 2001?
Your answer should be compact. 1.93. What is the ratio of the Aid flow (current US$) of Uganda in 1998 to that in 2001?
Keep it short and to the point. 0.33. What is the ratio of the Aid flow (current US$) of Low income in 1998 to that in 2002?
Provide a succinct answer. 0.88. What is the ratio of the Aid flow (current US$) in Georgia in 1998 to that in 2002?
Offer a very short reply. 0.63. What is the ratio of the Aid flow (current US$) of Iraq in 1998 to that in 2002?
Offer a very short reply. 1.66. What is the ratio of the Aid flow (current US$) in Uganda in 1998 to that in 2002?
Give a very brief answer. 0.41. What is the ratio of the Aid flow (current US$) in Low income in 1998 to that in 2003?
Your answer should be compact. 0.48. What is the ratio of the Aid flow (current US$) in Georgia in 1998 to that in 2003?
Ensure brevity in your answer.  0.52. What is the ratio of the Aid flow (current US$) in Iraq in 1998 to that in 2003?
Give a very brief answer. 0.61. What is the ratio of the Aid flow (current US$) of Uganda in 1998 to that in 2003?
Ensure brevity in your answer.  0.29. What is the ratio of the Aid flow (current US$) of Low income in 1998 to that in 2004?
Make the answer very short. 0.52. What is the ratio of the Aid flow (current US$) of Georgia in 1998 to that in 2004?
Your response must be concise. 0.31. What is the ratio of the Aid flow (current US$) in Iraq in 1998 to that in 2004?
Keep it short and to the point. 0.35. What is the ratio of the Aid flow (current US$) of Uganda in 1998 to that in 2004?
Offer a terse response. 0.23. What is the ratio of the Aid flow (current US$) of Low income in 1999 to that in 2000?
Your answer should be very brief. 0.9. What is the ratio of the Aid flow (current US$) of Georgia in 1999 to that in 2000?
Ensure brevity in your answer.  1.15. What is the ratio of the Aid flow (current US$) of Iraq in 1999 to that in 2000?
Provide a succinct answer. 1.2. What is the ratio of the Aid flow (current US$) of Uganda in 1999 to that in 2000?
Give a very brief answer. 0.9. What is the ratio of the Aid flow (current US$) of Low income in 1999 to that in 2001?
Keep it short and to the point. 0.91. What is the ratio of the Aid flow (current US$) in Georgia in 1999 to that in 2001?
Provide a succinct answer. 1.02. What is the ratio of the Aid flow (current US$) in Iraq in 1999 to that in 2001?
Your answer should be very brief. 2.24. What is the ratio of the Aid flow (current US$) of Uganda in 1999 to that in 2001?
Give a very brief answer. 0.69. What is the ratio of the Aid flow (current US$) of Low income in 1999 to that in 2002?
Your answer should be very brief. 0.88. What is the ratio of the Aid flow (current US$) in Iraq in 1999 to that in 2002?
Offer a terse response. 1.92. What is the ratio of the Aid flow (current US$) in Uganda in 1999 to that in 2002?
Keep it short and to the point. 0.87. What is the ratio of the Aid flow (current US$) of Low income in 1999 to that in 2003?
Offer a very short reply. 0.47. What is the ratio of the Aid flow (current US$) of Georgia in 1999 to that in 2003?
Give a very brief answer. 0.84. What is the ratio of the Aid flow (current US$) in Iraq in 1999 to that in 2003?
Offer a terse response. 0.71. What is the ratio of the Aid flow (current US$) in Uganda in 1999 to that in 2003?
Provide a succinct answer. 0.62. What is the ratio of the Aid flow (current US$) of Low income in 1999 to that in 2004?
Your answer should be compact. 0.51. What is the ratio of the Aid flow (current US$) in Georgia in 1999 to that in 2004?
Ensure brevity in your answer.  0.49. What is the ratio of the Aid flow (current US$) of Iraq in 1999 to that in 2004?
Provide a succinct answer. 0.41. What is the ratio of the Aid flow (current US$) of Uganda in 1999 to that in 2004?
Provide a succinct answer. 0.48. What is the ratio of the Aid flow (current US$) in Low income in 2000 to that in 2001?
Give a very brief answer. 1.02. What is the ratio of the Aid flow (current US$) of Georgia in 2000 to that in 2001?
Your answer should be compact. 0.89. What is the ratio of the Aid flow (current US$) in Iraq in 2000 to that in 2001?
Ensure brevity in your answer.  1.87. What is the ratio of the Aid flow (current US$) in Uganda in 2000 to that in 2001?
Give a very brief answer. 0.77. What is the ratio of the Aid flow (current US$) of Low income in 2000 to that in 2002?
Your answer should be very brief. 0.98. What is the ratio of the Aid flow (current US$) in Georgia in 2000 to that in 2002?
Give a very brief answer. 0.88. What is the ratio of the Aid flow (current US$) of Iraq in 2000 to that in 2002?
Keep it short and to the point. 1.61. What is the ratio of the Aid flow (current US$) of Uganda in 2000 to that in 2002?
Your response must be concise. 0.97. What is the ratio of the Aid flow (current US$) in Low income in 2000 to that in 2003?
Ensure brevity in your answer.  0.53. What is the ratio of the Aid flow (current US$) of Georgia in 2000 to that in 2003?
Ensure brevity in your answer.  0.73. What is the ratio of the Aid flow (current US$) in Iraq in 2000 to that in 2003?
Your response must be concise. 0.6. What is the ratio of the Aid flow (current US$) of Uganda in 2000 to that in 2003?
Make the answer very short. 0.69. What is the ratio of the Aid flow (current US$) in Low income in 2000 to that in 2004?
Offer a very short reply. 0.57. What is the ratio of the Aid flow (current US$) in Georgia in 2000 to that in 2004?
Make the answer very short. 0.43. What is the ratio of the Aid flow (current US$) in Iraq in 2000 to that in 2004?
Provide a short and direct response. 0.34. What is the ratio of the Aid flow (current US$) of Uganda in 2000 to that in 2004?
Offer a very short reply. 0.53. What is the ratio of the Aid flow (current US$) of Low income in 2001 to that in 2002?
Offer a very short reply. 0.96. What is the ratio of the Aid flow (current US$) of Georgia in 2001 to that in 2002?
Your answer should be compact. 0.99. What is the ratio of the Aid flow (current US$) in Iraq in 2001 to that in 2002?
Offer a terse response. 0.86. What is the ratio of the Aid flow (current US$) in Uganda in 2001 to that in 2002?
Provide a succinct answer. 1.26. What is the ratio of the Aid flow (current US$) of Low income in 2001 to that in 2003?
Provide a short and direct response. 0.52. What is the ratio of the Aid flow (current US$) of Georgia in 2001 to that in 2003?
Offer a very short reply. 0.82. What is the ratio of the Aid flow (current US$) in Iraq in 2001 to that in 2003?
Offer a terse response. 0.32. What is the ratio of the Aid flow (current US$) in Uganda in 2001 to that in 2003?
Keep it short and to the point. 0.89. What is the ratio of the Aid flow (current US$) in Low income in 2001 to that in 2004?
Your answer should be very brief. 0.56. What is the ratio of the Aid flow (current US$) of Georgia in 2001 to that in 2004?
Provide a succinct answer. 0.48. What is the ratio of the Aid flow (current US$) of Iraq in 2001 to that in 2004?
Provide a succinct answer. 0.18. What is the ratio of the Aid flow (current US$) of Uganda in 2001 to that in 2004?
Make the answer very short. 0.69. What is the ratio of the Aid flow (current US$) in Low income in 2002 to that in 2003?
Keep it short and to the point. 0.54. What is the ratio of the Aid flow (current US$) in Georgia in 2002 to that in 2003?
Offer a very short reply. 0.83. What is the ratio of the Aid flow (current US$) in Iraq in 2002 to that in 2003?
Offer a very short reply. 0.37. What is the ratio of the Aid flow (current US$) of Uganda in 2002 to that in 2003?
Offer a very short reply. 0.71. What is the ratio of the Aid flow (current US$) of Low income in 2002 to that in 2004?
Your answer should be very brief. 0.58. What is the ratio of the Aid flow (current US$) of Georgia in 2002 to that in 2004?
Make the answer very short. 0.49. What is the ratio of the Aid flow (current US$) of Iraq in 2002 to that in 2004?
Offer a very short reply. 0.21. What is the ratio of the Aid flow (current US$) in Uganda in 2002 to that in 2004?
Your answer should be compact. 0.55. What is the ratio of the Aid flow (current US$) of Low income in 2003 to that in 2004?
Offer a very short reply. 1.08. What is the ratio of the Aid flow (current US$) in Georgia in 2003 to that in 2004?
Ensure brevity in your answer.  0.59. What is the ratio of the Aid flow (current US$) of Iraq in 2003 to that in 2004?
Provide a succinct answer. 0.57. What is the ratio of the Aid flow (current US$) in Uganda in 2003 to that in 2004?
Your answer should be very brief. 0.77. What is the difference between the highest and the second highest Aid flow (current US$) of Low income?
Offer a terse response. 4.47e+07. What is the difference between the highest and the second highest Aid flow (current US$) of Georgia?
Offer a very short reply. 1.70e+06. What is the difference between the highest and the second highest Aid flow (current US$) in Iraq?
Provide a short and direct response. 2.33e+07. What is the difference between the highest and the second highest Aid flow (current US$) in Uganda?
Your answer should be compact. 9.82e+06. What is the difference between the highest and the lowest Aid flow (current US$) in Low income?
Make the answer very short. 3.02e+08. What is the difference between the highest and the lowest Aid flow (current US$) in Georgia?
Offer a very short reply. 3.53e+06. What is the difference between the highest and the lowest Aid flow (current US$) in Iraq?
Offer a very short reply. 4.07e+07. What is the difference between the highest and the lowest Aid flow (current US$) in Uganda?
Provide a short and direct response. 3.31e+07. 